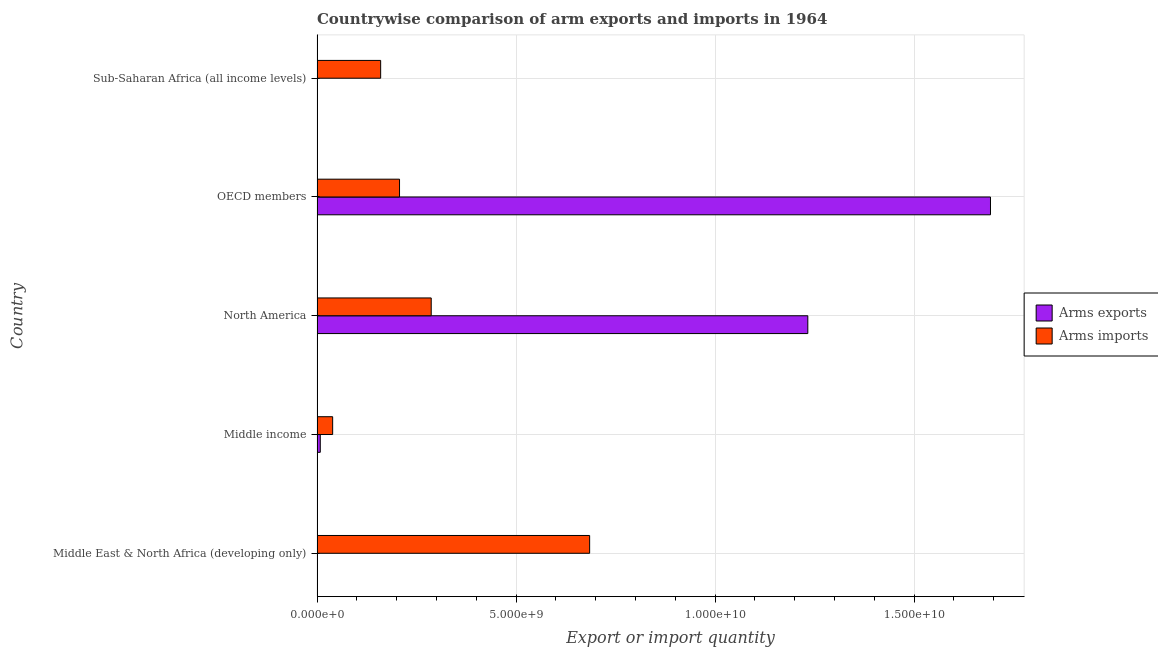Are the number of bars per tick equal to the number of legend labels?
Keep it short and to the point. Yes. Are the number of bars on each tick of the Y-axis equal?
Offer a very short reply. Yes. How many bars are there on the 2nd tick from the bottom?
Provide a succinct answer. 2. What is the label of the 3rd group of bars from the top?
Offer a very short reply. North America. What is the arms imports in Middle income?
Offer a very short reply. 3.92e+08. Across all countries, what is the maximum arms exports?
Make the answer very short. 1.69e+1. Across all countries, what is the minimum arms exports?
Your response must be concise. 2.00e+06. In which country was the arms imports maximum?
Your answer should be compact. Middle East & North Africa (developing only). In which country was the arms exports minimum?
Your answer should be compact. Middle East & North Africa (developing only). What is the total arms exports in the graph?
Your response must be concise. 2.93e+1. What is the difference between the arms exports in North America and that in Sub-Saharan Africa (all income levels)?
Keep it short and to the point. 1.23e+1. What is the difference between the arms exports in Sub-Saharan Africa (all income levels) and the arms imports in North America?
Make the answer very short. -2.86e+09. What is the average arms imports per country?
Your answer should be very brief. 2.76e+09. What is the difference between the arms exports and arms imports in Middle East & North Africa (developing only)?
Make the answer very short. -6.85e+09. In how many countries, is the arms exports greater than 6000000000 ?
Offer a very short reply. 2. What is the ratio of the arms exports in Middle East & North Africa (developing only) to that in Middle income?
Offer a terse response. 0.03. Is the arms imports in Middle income less than that in OECD members?
Give a very brief answer. Yes. Is the difference between the arms exports in Middle East & North Africa (developing only) and Sub-Saharan Africa (all income levels) greater than the difference between the arms imports in Middle East & North Africa (developing only) and Sub-Saharan Africa (all income levels)?
Give a very brief answer. No. What is the difference between the highest and the second highest arms imports?
Your response must be concise. 3.98e+09. What is the difference between the highest and the lowest arms imports?
Give a very brief answer. 6.46e+09. What does the 1st bar from the top in OECD members represents?
Your answer should be very brief. Arms imports. What does the 2nd bar from the bottom in North America represents?
Offer a very short reply. Arms imports. What is the difference between two consecutive major ticks on the X-axis?
Ensure brevity in your answer.  5.00e+09. Are the values on the major ticks of X-axis written in scientific E-notation?
Offer a terse response. Yes. Does the graph contain grids?
Offer a terse response. Yes. What is the title of the graph?
Give a very brief answer. Countrywise comparison of arm exports and imports in 1964. Does "Manufacturing industries and construction" appear as one of the legend labels in the graph?
Your answer should be very brief. No. What is the label or title of the X-axis?
Provide a succinct answer. Export or import quantity. What is the label or title of the Y-axis?
Give a very brief answer. Country. What is the Export or import quantity of Arms imports in Middle East & North Africa (developing only)?
Offer a very short reply. 6.85e+09. What is the Export or import quantity in Arms exports in Middle income?
Ensure brevity in your answer.  8.10e+07. What is the Export or import quantity of Arms imports in Middle income?
Provide a short and direct response. 3.92e+08. What is the Export or import quantity of Arms exports in North America?
Provide a succinct answer. 1.23e+1. What is the Export or import quantity of Arms imports in North America?
Your answer should be very brief. 2.87e+09. What is the Export or import quantity of Arms exports in OECD members?
Your answer should be compact. 1.69e+1. What is the Export or import quantity of Arms imports in OECD members?
Keep it short and to the point. 2.07e+09. What is the Export or import quantity of Arms imports in Sub-Saharan Africa (all income levels)?
Provide a succinct answer. 1.60e+09. Across all countries, what is the maximum Export or import quantity of Arms exports?
Ensure brevity in your answer.  1.69e+1. Across all countries, what is the maximum Export or import quantity in Arms imports?
Offer a very short reply. 6.85e+09. Across all countries, what is the minimum Export or import quantity in Arms imports?
Give a very brief answer. 3.92e+08. What is the total Export or import quantity of Arms exports in the graph?
Provide a short and direct response. 2.93e+1. What is the total Export or import quantity in Arms imports in the graph?
Provide a succinct answer. 1.38e+1. What is the difference between the Export or import quantity in Arms exports in Middle East & North Africa (developing only) and that in Middle income?
Ensure brevity in your answer.  -7.90e+07. What is the difference between the Export or import quantity in Arms imports in Middle East & North Africa (developing only) and that in Middle income?
Keep it short and to the point. 6.46e+09. What is the difference between the Export or import quantity in Arms exports in Middle East & North Africa (developing only) and that in North America?
Offer a very short reply. -1.23e+1. What is the difference between the Export or import quantity of Arms imports in Middle East & North Africa (developing only) and that in North America?
Keep it short and to the point. 3.98e+09. What is the difference between the Export or import quantity of Arms exports in Middle East & North Africa (developing only) and that in OECD members?
Provide a succinct answer. -1.69e+1. What is the difference between the Export or import quantity of Arms imports in Middle East & North Africa (developing only) and that in OECD members?
Ensure brevity in your answer.  4.78e+09. What is the difference between the Export or import quantity in Arms exports in Middle East & North Africa (developing only) and that in Sub-Saharan Africa (all income levels)?
Make the answer very short. -1.00e+06. What is the difference between the Export or import quantity in Arms imports in Middle East & North Africa (developing only) and that in Sub-Saharan Africa (all income levels)?
Your answer should be compact. 5.25e+09. What is the difference between the Export or import quantity of Arms exports in Middle income and that in North America?
Offer a terse response. -1.22e+1. What is the difference between the Export or import quantity of Arms imports in Middle income and that in North America?
Provide a succinct answer. -2.48e+09. What is the difference between the Export or import quantity of Arms exports in Middle income and that in OECD members?
Your answer should be very brief. -1.68e+1. What is the difference between the Export or import quantity of Arms imports in Middle income and that in OECD members?
Provide a succinct answer. -1.68e+09. What is the difference between the Export or import quantity of Arms exports in Middle income and that in Sub-Saharan Africa (all income levels)?
Provide a succinct answer. 7.80e+07. What is the difference between the Export or import quantity of Arms imports in Middle income and that in Sub-Saharan Africa (all income levels)?
Offer a very short reply. -1.21e+09. What is the difference between the Export or import quantity of Arms exports in North America and that in OECD members?
Provide a short and direct response. -4.59e+09. What is the difference between the Export or import quantity in Arms imports in North America and that in OECD members?
Ensure brevity in your answer.  7.96e+08. What is the difference between the Export or import quantity of Arms exports in North America and that in Sub-Saharan Africa (all income levels)?
Provide a succinct answer. 1.23e+1. What is the difference between the Export or import quantity of Arms imports in North America and that in Sub-Saharan Africa (all income levels)?
Ensure brevity in your answer.  1.27e+09. What is the difference between the Export or import quantity of Arms exports in OECD members and that in Sub-Saharan Africa (all income levels)?
Offer a very short reply. 1.69e+1. What is the difference between the Export or import quantity in Arms imports in OECD members and that in Sub-Saharan Africa (all income levels)?
Give a very brief answer. 4.74e+08. What is the difference between the Export or import quantity in Arms exports in Middle East & North Africa (developing only) and the Export or import quantity in Arms imports in Middle income?
Provide a succinct answer. -3.90e+08. What is the difference between the Export or import quantity in Arms exports in Middle East & North Africa (developing only) and the Export or import quantity in Arms imports in North America?
Offer a very short reply. -2.87e+09. What is the difference between the Export or import quantity of Arms exports in Middle East & North Africa (developing only) and the Export or import quantity of Arms imports in OECD members?
Make the answer very short. -2.07e+09. What is the difference between the Export or import quantity in Arms exports in Middle East & North Africa (developing only) and the Export or import quantity in Arms imports in Sub-Saharan Africa (all income levels)?
Provide a short and direct response. -1.60e+09. What is the difference between the Export or import quantity of Arms exports in Middle income and the Export or import quantity of Arms imports in North America?
Your answer should be compact. -2.79e+09. What is the difference between the Export or import quantity of Arms exports in Middle income and the Export or import quantity of Arms imports in OECD members?
Make the answer very short. -1.99e+09. What is the difference between the Export or import quantity of Arms exports in Middle income and the Export or import quantity of Arms imports in Sub-Saharan Africa (all income levels)?
Keep it short and to the point. -1.52e+09. What is the difference between the Export or import quantity in Arms exports in North America and the Export or import quantity in Arms imports in OECD members?
Keep it short and to the point. 1.03e+1. What is the difference between the Export or import quantity of Arms exports in North America and the Export or import quantity of Arms imports in Sub-Saharan Africa (all income levels)?
Offer a terse response. 1.07e+1. What is the difference between the Export or import quantity in Arms exports in OECD members and the Export or import quantity in Arms imports in Sub-Saharan Africa (all income levels)?
Provide a short and direct response. 1.53e+1. What is the average Export or import quantity in Arms exports per country?
Make the answer very short. 5.87e+09. What is the average Export or import quantity of Arms imports per country?
Offer a very short reply. 2.76e+09. What is the difference between the Export or import quantity in Arms exports and Export or import quantity in Arms imports in Middle East & North Africa (developing only)?
Your answer should be compact. -6.85e+09. What is the difference between the Export or import quantity of Arms exports and Export or import quantity of Arms imports in Middle income?
Your response must be concise. -3.11e+08. What is the difference between the Export or import quantity of Arms exports and Export or import quantity of Arms imports in North America?
Provide a short and direct response. 9.46e+09. What is the difference between the Export or import quantity of Arms exports and Export or import quantity of Arms imports in OECD members?
Provide a succinct answer. 1.48e+1. What is the difference between the Export or import quantity of Arms exports and Export or import quantity of Arms imports in Sub-Saharan Africa (all income levels)?
Make the answer very short. -1.60e+09. What is the ratio of the Export or import quantity in Arms exports in Middle East & North Africa (developing only) to that in Middle income?
Offer a very short reply. 0.02. What is the ratio of the Export or import quantity of Arms imports in Middle East & North Africa (developing only) to that in Middle income?
Offer a terse response. 17.47. What is the ratio of the Export or import quantity of Arms exports in Middle East & North Africa (developing only) to that in North America?
Give a very brief answer. 0. What is the ratio of the Export or import quantity of Arms imports in Middle East & North Africa (developing only) to that in North America?
Your answer should be compact. 2.39. What is the ratio of the Export or import quantity of Arms imports in Middle East & North Africa (developing only) to that in OECD members?
Offer a very short reply. 3.31. What is the ratio of the Export or import quantity of Arms imports in Middle East & North Africa (developing only) to that in Sub-Saharan Africa (all income levels)?
Provide a succinct answer. 4.29. What is the ratio of the Export or import quantity of Arms exports in Middle income to that in North America?
Provide a succinct answer. 0.01. What is the ratio of the Export or import quantity of Arms imports in Middle income to that in North America?
Make the answer very short. 0.14. What is the ratio of the Export or import quantity of Arms exports in Middle income to that in OECD members?
Offer a terse response. 0. What is the ratio of the Export or import quantity in Arms imports in Middle income to that in OECD members?
Ensure brevity in your answer.  0.19. What is the ratio of the Export or import quantity in Arms exports in Middle income to that in Sub-Saharan Africa (all income levels)?
Offer a very short reply. 27. What is the ratio of the Export or import quantity of Arms imports in Middle income to that in Sub-Saharan Africa (all income levels)?
Ensure brevity in your answer.  0.25. What is the ratio of the Export or import quantity in Arms exports in North America to that in OECD members?
Provide a short and direct response. 0.73. What is the ratio of the Export or import quantity of Arms imports in North America to that in OECD members?
Offer a very short reply. 1.38. What is the ratio of the Export or import quantity in Arms exports in North America to that in Sub-Saharan Africa (all income levels)?
Make the answer very short. 4109.67. What is the ratio of the Export or import quantity of Arms imports in North America to that in Sub-Saharan Africa (all income levels)?
Your response must be concise. 1.79. What is the ratio of the Export or import quantity in Arms exports in OECD members to that in Sub-Saharan Africa (all income levels)?
Provide a succinct answer. 5639.33. What is the ratio of the Export or import quantity of Arms imports in OECD members to that in Sub-Saharan Africa (all income levels)?
Give a very brief answer. 1.3. What is the difference between the highest and the second highest Export or import quantity of Arms exports?
Your answer should be compact. 4.59e+09. What is the difference between the highest and the second highest Export or import quantity in Arms imports?
Ensure brevity in your answer.  3.98e+09. What is the difference between the highest and the lowest Export or import quantity of Arms exports?
Provide a succinct answer. 1.69e+1. What is the difference between the highest and the lowest Export or import quantity in Arms imports?
Make the answer very short. 6.46e+09. 